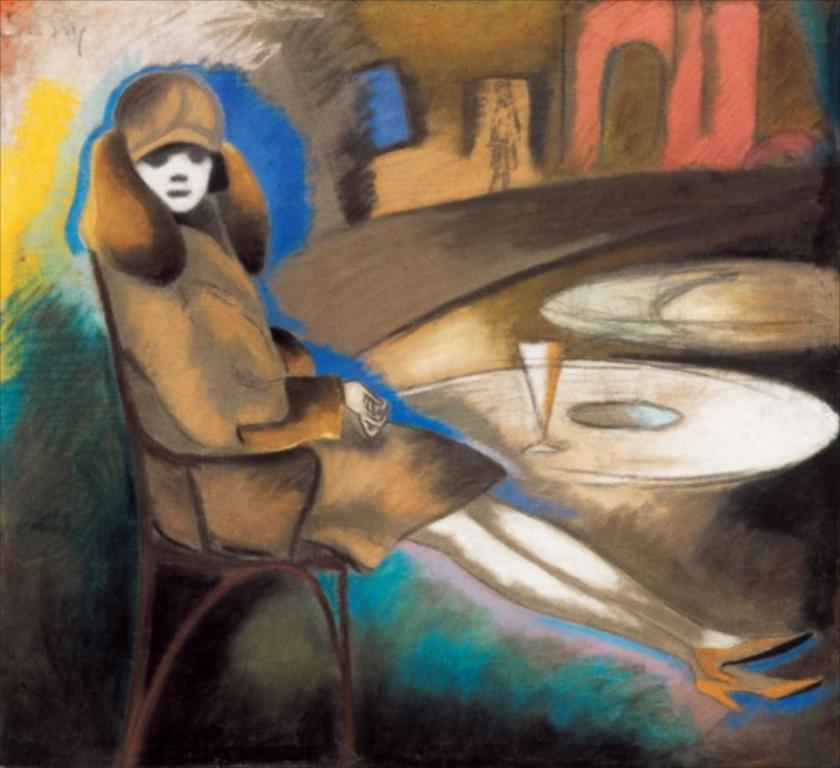What is depicted on the wall in the image? There is graffiti on a wall in the image. What type of harmony can be seen in the clouds above the graffiti in the image? There are no clouds present in the image, and therefore no harmony can be observed in them. 